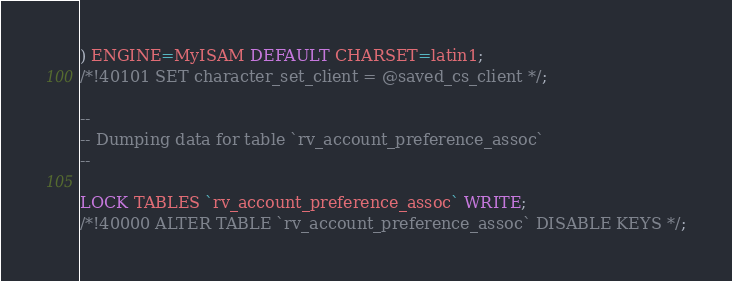Convert code to text. <code><loc_0><loc_0><loc_500><loc_500><_SQL_>) ENGINE=MyISAM DEFAULT CHARSET=latin1;
/*!40101 SET character_set_client = @saved_cs_client */;

--
-- Dumping data for table `rv_account_preference_assoc`
--

LOCK TABLES `rv_account_preference_assoc` WRITE;
/*!40000 ALTER TABLE `rv_account_preference_assoc` DISABLE KEYS */;</code> 